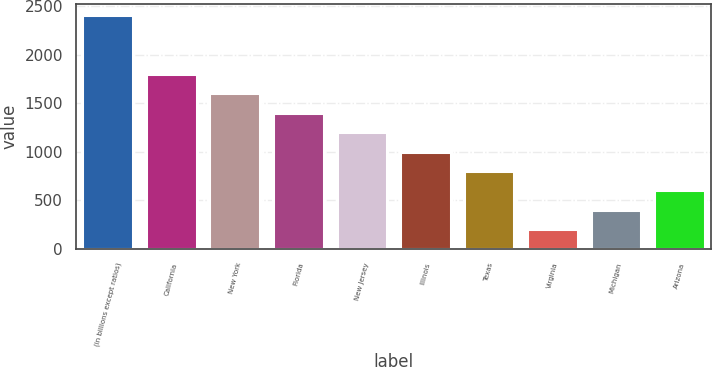Convert chart to OTSL. <chart><loc_0><loc_0><loc_500><loc_500><bar_chart><fcel>(in billions except ratios)<fcel>California<fcel>New York<fcel>Florida<fcel>New Jersey<fcel>Illinois<fcel>Texas<fcel>Virginia<fcel>Michigan<fcel>Arizona<nl><fcel>2406.92<fcel>1805.54<fcel>1605.08<fcel>1404.62<fcel>1204.16<fcel>1003.7<fcel>803.24<fcel>201.86<fcel>402.32<fcel>602.78<nl></chart> 